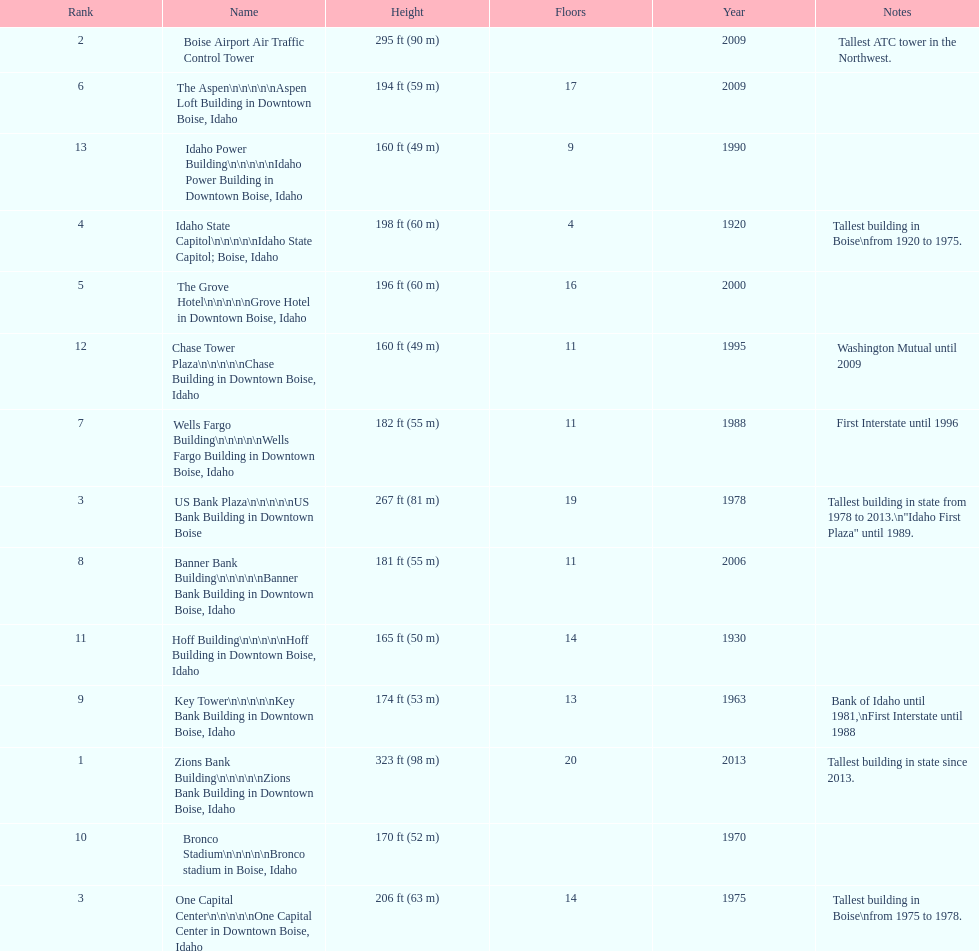What is the number of floors of the oldest building? 4. 